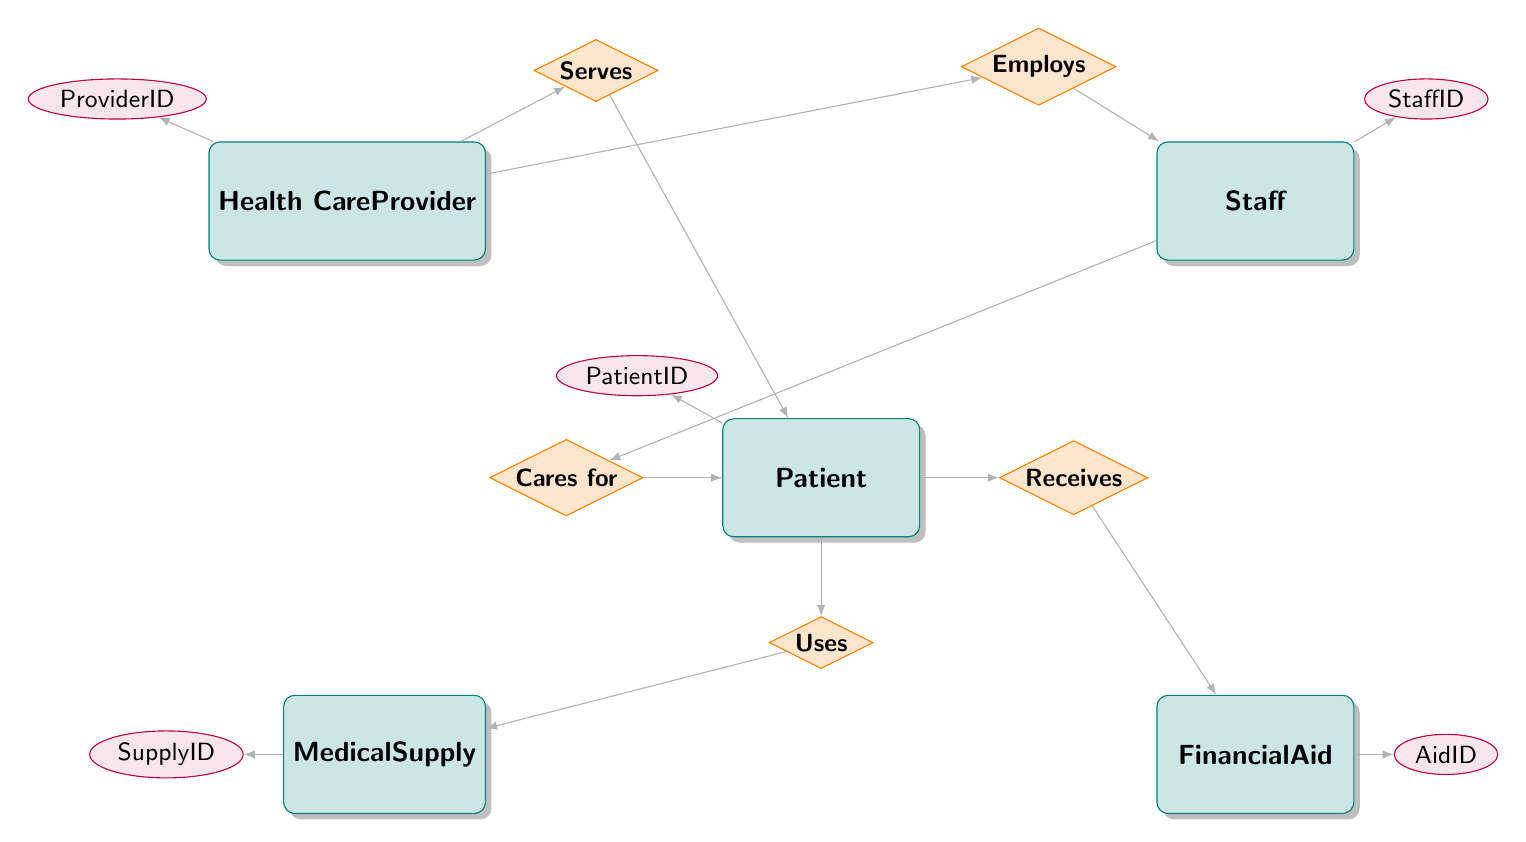What is the primary key of the Health Care Provider entity? The primary key of the Health Care Provider entity is indicated by the label on its attribute connected to it. In this case, it is "ProviderID".
Answer: ProviderID How many entities are there in the diagram? By counting the boxes that represent entities, we find there are five entities: Health Care Provider, Patient, Medical Supply, Financial Aid, and Staff.
Answer: 5 What kind of relationship exists between Health Care Provider and Patient? The type of relationship is indicated by the diamond labeled "Serves", which is a "One-to-Many" relationship where one provider can serve multiple patients.
Answer: One-to-Many Which entity is responsible for receiving Financial Aid? The relationship labeled "Receives" connects the Patient entity to the Financial Aid entity, indicating that patients are the ones receiving financial aid.
Answer: Patient What is the role of the Staff entity in relation to Patient? The diagram shows a diamond labeled "Cares for" connecting Staff and Patient, which indicates that staff members are responsible for the care of patients.
Answer: Cares for How many supplies can a Patient use? The relationship labeled "Uses" between Patient and Medical Supply indicates a "Many-to-Many" relationship, meaning a patient can use multiple supplies and each supply can be used by multiple patients.
Answer: Many-to-Many What is the primary key of the Financial Aid entity? The primary key of the Financial Aid entity is marked on its attribute connected to it, which is "AidID."
Answer: AidID Who employs the Staff in the diagram? The relationship labeled "Employs" connects the Health Care Provider to the Staff entity, indicating that providers are the ones who employ staff members.
Answer: Health Care Provider What is the primary key of the Medical Supply entity? The primary key for the Medical Supply entity is indicated by its linking attribute, which is "SupplyID."
Answer: SupplyID 